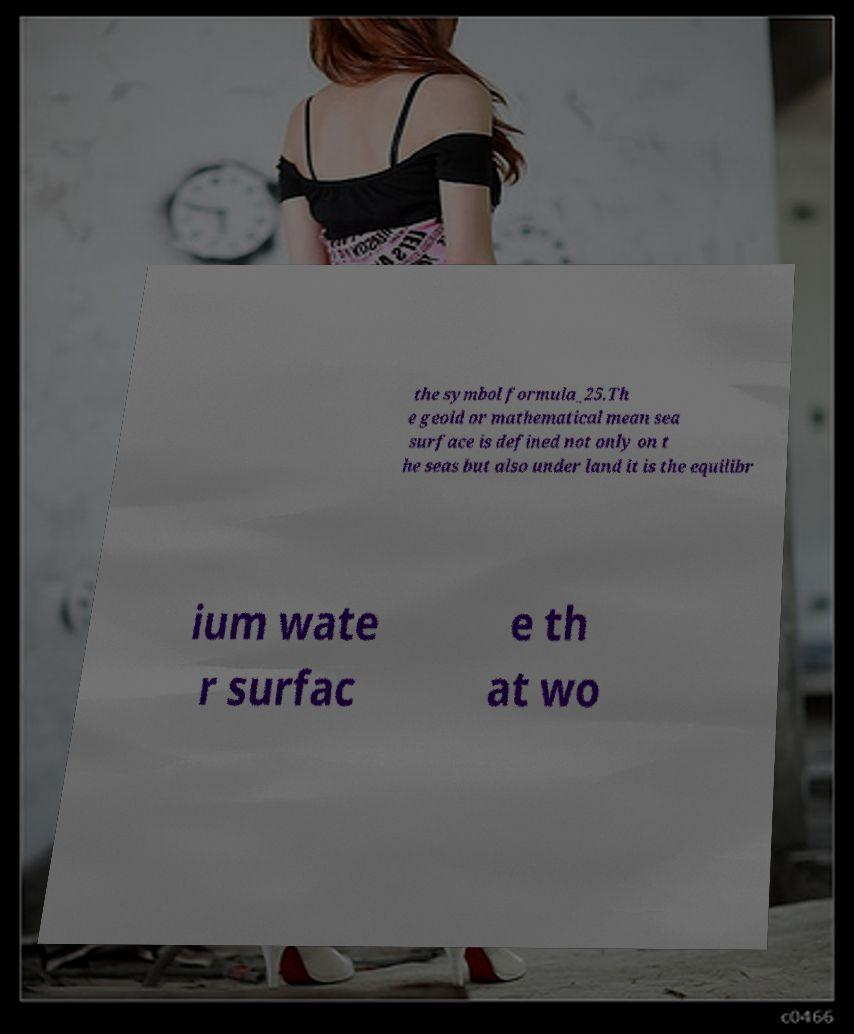I need the written content from this picture converted into text. Can you do that? the symbol formula_25.Th e geoid or mathematical mean sea surface is defined not only on t he seas but also under land it is the equilibr ium wate r surfac e th at wo 